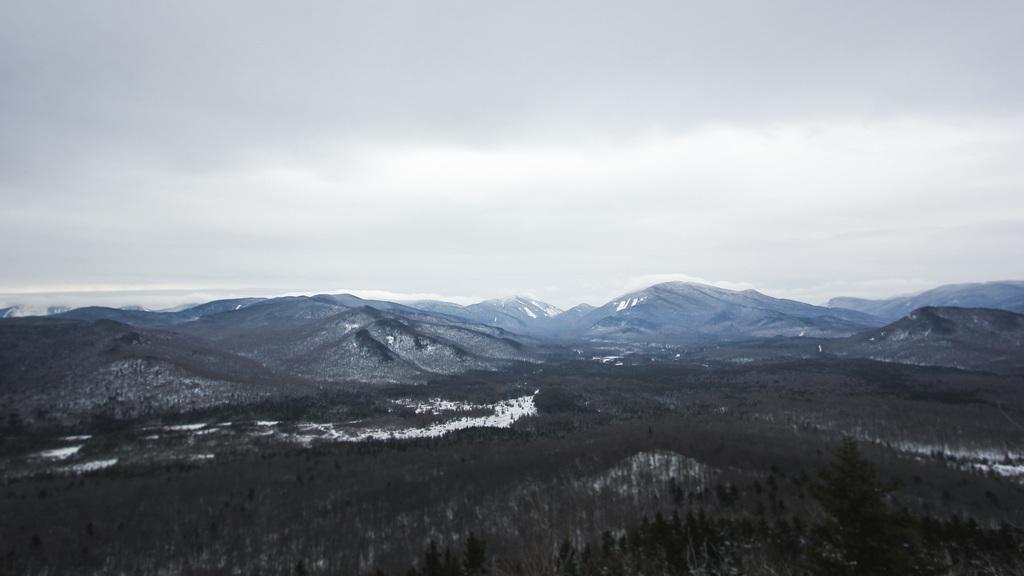Please provide a concise description of this image. In this image we can see the mountains, trees, snow and also the cloudy sky. 